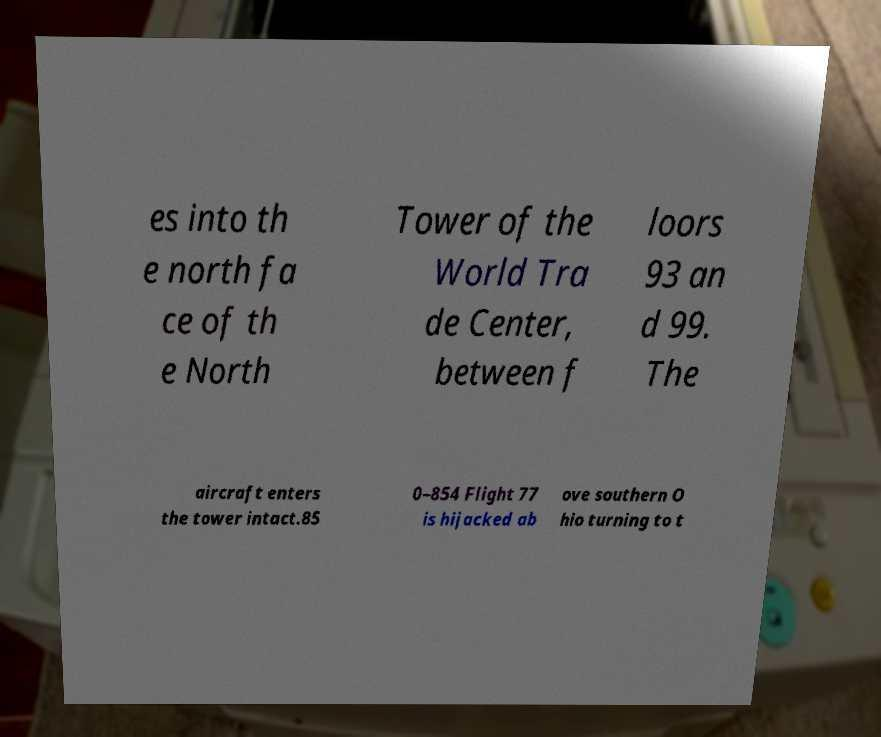Please read and relay the text visible in this image. What does it say? es into th e north fa ce of th e North Tower of the World Tra de Center, between f loors 93 an d 99. The aircraft enters the tower intact.85 0–854 Flight 77 is hijacked ab ove southern O hio turning to t 